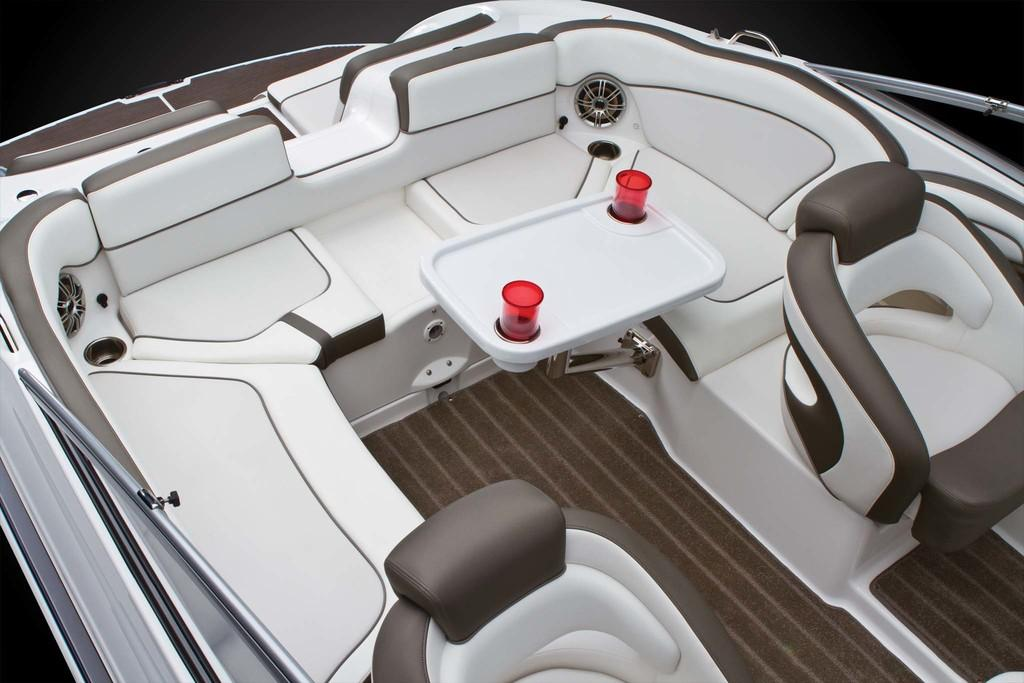What can be found inside the boat in the image? There are cups in the boat. What is provided for passengers to sit on in the boat? There are seats in the boat. What type of blade is being used to cut the parcel in the boat? There is no blade or parcel present in the image; the image only shows cups and seats in a boat. 